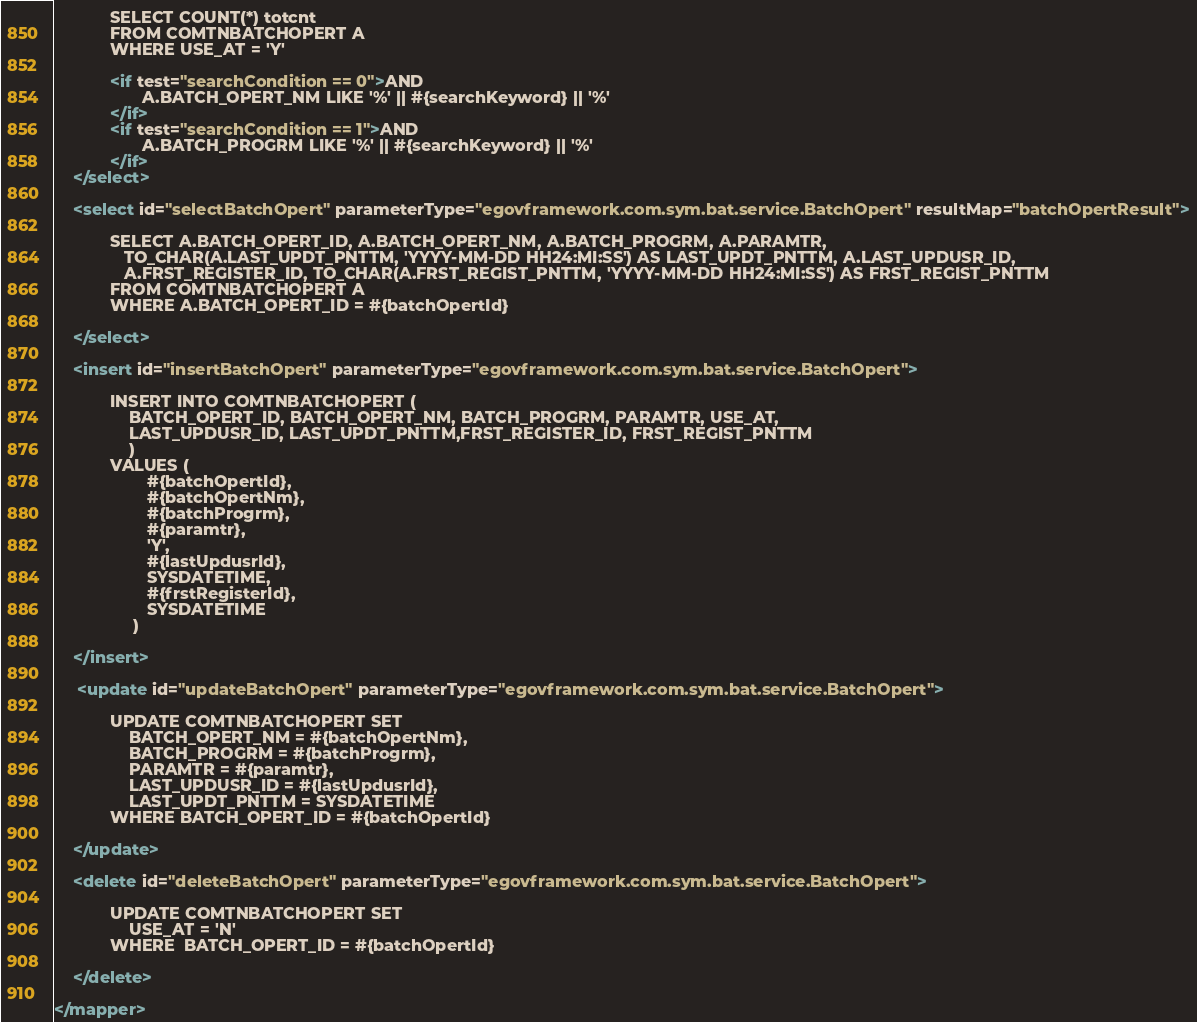<code> <loc_0><loc_0><loc_500><loc_500><_XML_>            SELECT COUNT(*) totcnt
            FROM COMTNBATCHOPERT A
            WHERE USE_AT = 'Y'
        
            <if test="searchCondition == 0">AND
                   A.BATCH_OPERT_NM LIKE '%' || #{searchKeyword} || '%'        
            </if>
            <if test="searchCondition == 1">AND
                   A.BATCH_PROGRM LIKE '%' || #{searchKeyword} || '%'        
            </if>
    </select>
    
    <select id="selectBatchOpert" parameterType="egovframework.com.sym.bat.service.BatchOpert" resultMap="batchOpertResult">
        
            SELECT A.BATCH_OPERT_ID, A.BATCH_OPERT_NM, A.BATCH_PROGRM, A.PARAMTR, 
               TO_CHAR(A.LAST_UPDT_PNTTM, 'YYYY-MM-DD HH24:MI:SS') AS LAST_UPDT_PNTTM, A.LAST_UPDUSR_ID,
               A.FRST_REGISTER_ID, TO_CHAR(A.FRST_REGIST_PNTTM, 'YYYY-MM-DD HH24:MI:SS') AS FRST_REGIST_PNTTM
            FROM COMTNBATCHOPERT A
            WHERE A.BATCH_OPERT_ID = #{batchOpertId}
        
    </select>

    <insert id="insertBatchOpert" parameterType="egovframework.com.sym.bat.service.BatchOpert">
        
            INSERT INTO COMTNBATCHOPERT (
                BATCH_OPERT_ID, BATCH_OPERT_NM, BATCH_PROGRM, PARAMTR, USE_AT,
                LAST_UPDUSR_ID, LAST_UPDT_PNTTM,FRST_REGISTER_ID, FRST_REGIST_PNTTM
                ) 
            VALUES (
                    #{batchOpertId},  
                    #{batchOpertNm},
                    #{batchProgrm},
                    #{paramtr},
                    'Y',
                    #{lastUpdusrId},
                    SYSDATETIME,
                    #{frstRegisterId},
                    SYSDATETIME
                 ) 
        
    </insert>

     <update id="updateBatchOpert" parameterType="egovframework.com.sym.bat.service.BatchOpert">
        
            UPDATE COMTNBATCHOPERT SET 
                BATCH_OPERT_NM = #{batchOpertNm},
                BATCH_PROGRM = #{batchProgrm},
                PARAMTR = #{paramtr},
                LAST_UPDUSR_ID = #{lastUpdusrId},
                LAST_UPDT_PNTTM = SYSDATETIME
            WHERE BATCH_OPERT_ID = #{batchOpertId} 
        
    </update>
    
    <delete id="deleteBatchOpert" parameterType="egovframework.com.sym.bat.service.BatchOpert">
        
            UPDATE COMTNBATCHOPERT SET
                USE_AT = 'N'
            WHERE  BATCH_OPERT_ID = #{batchOpertId} 
        
    </delete>

</mapper></code> 